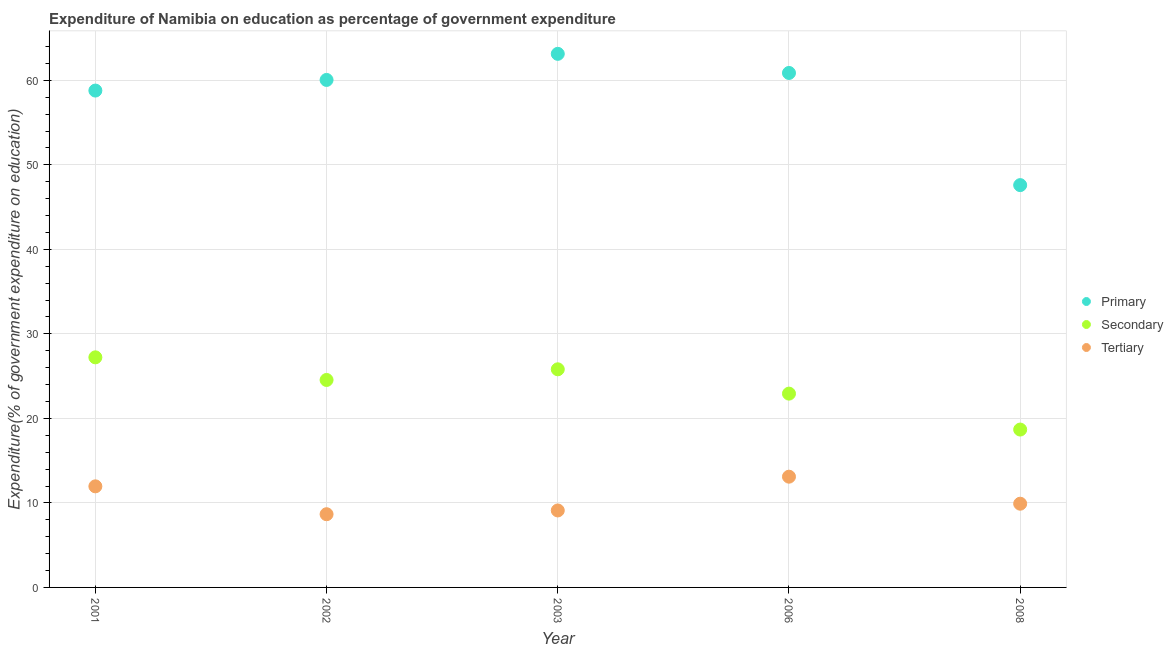What is the expenditure on tertiary education in 2008?
Offer a terse response. 9.91. Across all years, what is the maximum expenditure on tertiary education?
Your response must be concise. 13.1. Across all years, what is the minimum expenditure on tertiary education?
Ensure brevity in your answer.  8.66. What is the total expenditure on secondary education in the graph?
Provide a succinct answer. 119.19. What is the difference between the expenditure on primary education in 2001 and that in 2008?
Provide a succinct answer. 11.19. What is the difference between the expenditure on primary education in 2006 and the expenditure on tertiary education in 2002?
Keep it short and to the point. 52.21. What is the average expenditure on secondary education per year?
Offer a very short reply. 23.84. In the year 2003, what is the difference between the expenditure on secondary education and expenditure on primary education?
Provide a short and direct response. -37.32. What is the ratio of the expenditure on secondary education in 2001 to that in 2003?
Provide a succinct answer. 1.05. Is the expenditure on tertiary education in 2002 less than that in 2006?
Keep it short and to the point. Yes. What is the difference between the highest and the second highest expenditure on tertiary education?
Ensure brevity in your answer.  1.14. What is the difference between the highest and the lowest expenditure on secondary education?
Offer a very short reply. 8.55. In how many years, is the expenditure on primary education greater than the average expenditure on primary education taken over all years?
Offer a very short reply. 4. Is it the case that in every year, the sum of the expenditure on primary education and expenditure on secondary education is greater than the expenditure on tertiary education?
Ensure brevity in your answer.  Yes. How many dotlines are there?
Give a very brief answer. 3. Does the graph contain grids?
Ensure brevity in your answer.  Yes. What is the title of the graph?
Keep it short and to the point. Expenditure of Namibia on education as percentage of government expenditure. What is the label or title of the X-axis?
Keep it short and to the point. Year. What is the label or title of the Y-axis?
Give a very brief answer. Expenditure(% of government expenditure on education). What is the Expenditure(% of government expenditure on education) in Primary in 2001?
Offer a very short reply. 58.79. What is the Expenditure(% of government expenditure on education) in Secondary in 2001?
Your response must be concise. 27.22. What is the Expenditure(% of government expenditure on education) in Tertiary in 2001?
Ensure brevity in your answer.  11.96. What is the Expenditure(% of government expenditure on education) in Primary in 2002?
Ensure brevity in your answer.  60.05. What is the Expenditure(% of government expenditure on education) in Secondary in 2002?
Your answer should be very brief. 24.55. What is the Expenditure(% of government expenditure on education) of Tertiary in 2002?
Your response must be concise. 8.66. What is the Expenditure(% of government expenditure on education) in Primary in 2003?
Your response must be concise. 63.13. What is the Expenditure(% of government expenditure on education) in Secondary in 2003?
Your answer should be compact. 25.81. What is the Expenditure(% of government expenditure on education) in Tertiary in 2003?
Provide a succinct answer. 9.11. What is the Expenditure(% of government expenditure on education) in Primary in 2006?
Your answer should be very brief. 60.87. What is the Expenditure(% of government expenditure on education) in Secondary in 2006?
Your answer should be very brief. 22.93. What is the Expenditure(% of government expenditure on education) in Tertiary in 2006?
Offer a very short reply. 13.1. What is the Expenditure(% of government expenditure on education) in Primary in 2008?
Give a very brief answer. 47.6. What is the Expenditure(% of government expenditure on education) in Secondary in 2008?
Provide a short and direct response. 18.68. What is the Expenditure(% of government expenditure on education) of Tertiary in 2008?
Offer a terse response. 9.91. Across all years, what is the maximum Expenditure(% of government expenditure on education) in Primary?
Make the answer very short. 63.13. Across all years, what is the maximum Expenditure(% of government expenditure on education) in Secondary?
Provide a succinct answer. 27.22. Across all years, what is the maximum Expenditure(% of government expenditure on education) of Tertiary?
Offer a terse response. 13.1. Across all years, what is the minimum Expenditure(% of government expenditure on education) of Primary?
Your answer should be very brief. 47.6. Across all years, what is the minimum Expenditure(% of government expenditure on education) in Secondary?
Offer a very short reply. 18.68. Across all years, what is the minimum Expenditure(% of government expenditure on education) of Tertiary?
Provide a short and direct response. 8.66. What is the total Expenditure(% of government expenditure on education) in Primary in the graph?
Your answer should be compact. 290.44. What is the total Expenditure(% of government expenditure on education) of Secondary in the graph?
Make the answer very short. 119.19. What is the total Expenditure(% of government expenditure on education) in Tertiary in the graph?
Provide a succinct answer. 52.74. What is the difference between the Expenditure(% of government expenditure on education) of Primary in 2001 and that in 2002?
Your answer should be very brief. -1.26. What is the difference between the Expenditure(% of government expenditure on education) in Secondary in 2001 and that in 2002?
Ensure brevity in your answer.  2.68. What is the difference between the Expenditure(% of government expenditure on education) in Tertiary in 2001 and that in 2002?
Your answer should be very brief. 3.3. What is the difference between the Expenditure(% of government expenditure on education) in Primary in 2001 and that in 2003?
Give a very brief answer. -4.35. What is the difference between the Expenditure(% of government expenditure on education) in Secondary in 2001 and that in 2003?
Offer a terse response. 1.42. What is the difference between the Expenditure(% of government expenditure on education) of Tertiary in 2001 and that in 2003?
Offer a terse response. 2.85. What is the difference between the Expenditure(% of government expenditure on education) in Primary in 2001 and that in 2006?
Ensure brevity in your answer.  -2.08. What is the difference between the Expenditure(% of government expenditure on education) in Secondary in 2001 and that in 2006?
Offer a very short reply. 4.29. What is the difference between the Expenditure(% of government expenditure on education) in Tertiary in 2001 and that in 2006?
Your response must be concise. -1.14. What is the difference between the Expenditure(% of government expenditure on education) of Primary in 2001 and that in 2008?
Your response must be concise. 11.19. What is the difference between the Expenditure(% of government expenditure on education) of Secondary in 2001 and that in 2008?
Your answer should be compact. 8.55. What is the difference between the Expenditure(% of government expenditure on education) of Tertiary in 2001 and that in 2008?
Make the answer very short. 2.05. What is the difference between the Expenditure(% of government expenditure on education) in Primary in 2002 and that in 2003?
Keep it short and to the point. -3.09. What is the difference between the Expenditure(% of government expenditure on education) in Secondary in 2002 and that in 2003?
Your answer should be compact. -1.26. What is the difference between the Expenditure(% of government expenditure on education) of Tertiary in 2002 and that in 2003?
Offer a very short reply. -0.45. What is the difference between the Expenditure(% of government expenditure on education) in Primary in 2002 and that in 2006?
Your answer should be very brief. -0.83. What is the difference between the Expenditure(% of government expenditure on education) in Secondary in 2002 and that in 2006?
Keep it short and to the point. 1.62. What is the difference between the Expenditure(% of government expenditure on education) in Tertiary in 2002 and that in 2006?
Ensure brevity in your answer.  -4.44. What is the difference between the Expenditure(% of government expenditure on education) of Primary in 2002 and that in 2008?
Keep it short and to the point. 12.45. What is the difference between the Expenditure(% of government expenditure on education) of Secondary in 2002 and that in 2008?
Offer a terse response. 5.87. What is the difference between the Expenditure(% of government expenditure on education) in Tertiary in 2002 and that in 2008?
Your answer should be compact. -1.24. What is the difference between the Expenditure(% of government expenditure on education) in Primary in 2003 and that in 2006?
Your answer should be compact. 2.26. What is the difference between the Expenditure(% of government expenditure on education) of Secondary in 2003 and that in 2006?
Give a very brief answer. 2.88. What is the difference between the Expenditure(% of government expenditure on education) in Tertiary in 2003 and that in 2006?
Your response must be concise. -4. What is the difference between the Expenditure(% of government expenditure on education) of Primary in 2003 and that in 2008?
Your answer should be compact. 15.53. What is the difference between the Expenditure(% of government expenditure on education) of Secondary in 2003 and that in 2008?
Offer a terse response. 7.13. What is the difference between the Expenditure(% of government expenditure on education) of Tertiary in 2003 and that in 2008?
Your response must be concise. -0.8. What is the difference between the Expenditure(% of government expenditure on education) in Primary in 2006 and that in 2008?
Keep it short and to the point. 13.27. What is the difference between the Expenditure(% of government expenditure on education) of Secondary in 2006 and that in 2008?
Offer a terse response. 4.25. What is the difference between the Expenditure(% of government expenditure on education) in Tertiary in 2006 and that in 2008?
Ensure brevity in your answer.  3.2. What is the difference between the Expenditure(% of government expenditure on education) in Primary in 2001 and the Expenditure(% of government expenditure on education) in Secondary in 2002?
Offer a very short reply. 34.24. What is the difference between the Expenditure(% of government expenditure on education) of Primary in 2001 and the Expenditure(% of government expenditure on education) of Tertiary in 2002?
Your answer should be very brief. 50.13. What is the difference between the Expenditure(% of government expenditure on education) of Secondary in 2001 and the Expenditure(% of government expenditure on education) of Tertiary in 2002?
Your answer should be very brief. 18.56. What is the difference between the Expenditure(% of government expenditure on education) in Primary in 2001 and the Expenditure(% of government expenditure on education) in Secondary in 2003?
Give a very brief answer. 32.98. What is the difference between the Expenditure(% of government expenditure on education) of Primary in 2001 and the Expenditure(% of government expenditure on education) of Tertiary in 2003?
Keep it short and to the point. 49.68. What is the difference between the Expenditure(% of government expenditure on education) in Secondary in 2001 and the Expenditure(% of government expenditure on education) in Tertiary in 2003?
Give a very brief answer. 18.12. What is the difference between the Expenditure(% of government expenditure on education) in Primary in 2001 and the Expenditure(% of government expenditure on education) in Secondary in 2006?
Make the answer very short. 35.86. What is the difference between the Expenditure(% of government expenditure on education) of Primary in 2001 and the Expenditure(% of government expenditure on education) of Tertiary in 2006?
Your response must be concise. 45.68. What is the difference between the Expenditure(% of government expenditure on education) of Secondary in 2001 and the Expenditure(% of government expenditure on education) of Tertiary in 2006?
Ensure brevity in your answer.  14.12. What is the difference between the Expenditure(% of government expenditure on education) in Primary in 2001 and the Expenditure(% of government expenditure on education) in Secondary in 2008?
Make the answer very short. 40.11. What is the difference between the Expenditure(% of government expenditure on education) in Primary in 2001 and the Expenditure(% of government expenditure on education) in Tertiary in 2008?
Give a very brief answer. 48.88. What is the difference between the Expenditure(% of government expenditure on education) in Secondary in 2001 and the Expenditure(% of government expenditure on education) in Tertiary in 2008?
Provide a short and direct response. 17.32. What is the difference between the Expenditure(% of government expenditure on education) in Primary in 2002 and the Expenditure(% of government expenditure on education) in Secondary in 2003?
Keep it short and to the point. 34.24. What is the difference between the Expenditure(% of government expenditure on education) in Primary in 2002 and the Expenditure(% of government expenditure on education) in Tertiary in 2003?
Give a very brief answer. 50.94. What is the difference between the Expenditure(% of government expenditure on education) of Secondary in 2002 and the Expenditure(% of government expenditure on education) of Tertiary in 2003?
Ensure brevity in your answer.  15.44. What is the difference between the Expenditure(% of government expenditure on education) in Primary in 2002 and the Expenditure(% of government expenditure on education) in Secondary in 2006?
Ensure brevity in your answer.  37.12. What is the difference between the Expenditure(% of government expenditure on education) of Primary in 2002 and the Expenditure(% of government expenditure on education) of Tertiary in 2006?
Make the answer very short. 46.94. What is the difference between the Expenditure(% of government expenditure on education) in Secondary in 2002 and the Expenditure(% of government expenditure on education) in Tertiary in 2006?
Your answer should be compact. 11.44. What is the difference between the Expenditure(% of government expenditure on education) in Primary in 2002 and the Expenditure(% of government expenditure on education) in Secondary in 2008?
Your answer should be very brief. 41.37. What is the difference between the Expenditure(% of government expenditure on education) of Primary in 2002 and the Expenditure(% of government expenditure on education) of Tertiary in 2008?
Make the answer very short. 50.14. What is the difference between the Expenditure(% of government expenditure on education) of Secondary in 2002 and the Expenditure(% of government expenditure on education) of Tertiary in 2008?
Ensure brevity in your answer.  14.64. What is the difference between the Expenditure(% of government expenditure on education) of Primary in 2003 and the Expenditure(% of government expenditure on education) of Secondary in 2006?
Offer a terse response. 40.2. What is the difference between the Expenditure(% of government expenditure on education) of Primary in 2003 and the Expenditure(% of government expenditure on education) of Tertiary in 2006?
Give a very brief answer. 50.03. What is the difference between the Expenditure(% of government expenditure on education) of Secondary in 2003 and the Expenditure(% of government expenditure on education) of Tertiary in 2006?
Provide a succinct answer. 12.7. What is the difference between the Expenditure(% of government expenditure on education) of Primary in 2003 and the Expenditure(% of government expenditure on education) of Secondary in 2008?
Your answer should be very brief. 44.45. What is the difference between the Expenditure(% of government expenditure on education) in Primary in 2003 and the Expenditure(% of government expenditure on education) in Tertiary in 2008?
Give a very brief answer. 53.23. What is the difference between the Expenditure(% of government expenditure on education) of Secondary in 2003 and the Expenditure(% of government expenditure on education) of Tertiary in 2008?
Offer a very short reply. 15.9. What is the difference between the Expenditure(% of government expenditure on education) in Primary in 2006 and the Expenditure(% of government expenditure on education) in Secondary in 2008?
Your response must be concise. 42.19. What is the difference between the Expenditure(% of government expenditure on education) of Primary in 2006 and the Expenditure(% of government expenditure on education) of Tertiary in 2008?
Make the answer very short. 50.97. What is the difference between the Expenditure(% of government expenditure on education) of Secondary in 2006 and the Expenditure(% of government expenditure on education) of Tertiary in 2008?
Provide a succinct answer. 13.02. What is the average Expenditure(% of government expenditure on education) in Primary per year?
Offer a terse response. 58.09. What is the average Expenditure(% of government expenditure on education) in Secondary per year?
Your answer should be compact. 23.84. What is the average Expenditure(% of government expenditure on education) of Tertiary per year?
Your answer should be very brief. 10.55. In the year 2001, what is the difference between the Expenditure(% of government expenditure on education) in Primary and Expenditure(% of government expenditure on education) in Secondary?
Keep it short and to the point. 31.56. In the year 2001, what is the difference between the Expenditure(% of government expenditure on education) in Primary and Expenditure(% of government expenditure on education) in Tertiary?
Give a very brief answer. 46.83. In the year 2001, what is the difference between the Expenditure(% of government expenditure on education) of Secondary and Expenditure(% of government expenditure on education) of Tertiary?
Offer a very short reply. 15.26. In the year 2002, what is the difference between the Expenditure(% of government expenditure on education) in Primary and Expenditure(% of government expenditure on education) in Secondary?
Your response must be concise. 35.5. In the year 2002, what is the difference between the Expenditure(% of government expenditure on education) of Primary and Expenditure(% of government expenditure on education) of Tertiary?
Offer a very short reply. 51.38. In the year 2002, what is the difference between the Expenditure(% of government expenditure on education) in Secondary and Expenditure(% of government expenditure on education) in Tertiary?
Offer a terse response. 15.88. In the year 2003, what is the difference between the Expenditure(% of government expenditure on education) in Primary and Expenditure(% of government expenditure on education) in Secondary?
Offer a very short reply. 37.32. In the year 2003, what is the difference between the Expenditure(% of government expenditure on education) in Primary and Expenditure(% of government expenditure on education) in Tertiary?
Make the answer very short. 54.03. In the year 2003, what is the difference between the Expenditure(% of government expenditure on education) of Secondary and Expenditure(% of government expenditure on education) of Tertiary?
Your answer should be very brief. 16.7. In the year 2006, what is the difference between the Expenditure(% of government expenditure on education) of Primary and Expenditure(% of government expenditure on education) of Secondary?
Provide a succinct answer. 37.94. In the year 2006, what is the difference between the Expenditure(% of government expenditure on education) of Primary and Expenditure(% of government expenditure on education) of Tertiary?
Your response must be concise. 47.77. In the year 2006, what is the difference between the Expenditure(% of government expenditure on education) of Secondary and Expenditure(% of government expenditure on education) of Tertiary?
Ensure brevity in your answer.  9.83. In the year 2008, what is the difference between the Expenditure(% of government expenditure on education) of Primary and Expenditure(% of government expenditure on education) of Secondary?
Offer a terse response. 28.92. In the year 2008, what is the difference between the Expenditure(% of government expenditure on education) in Primary and Expenditure(% of government expenditure on education) in Tertiary?
Make the answer very short. 37.69. In the year 2008, what is the difference between the Expenditure(% of government expenditure on education) in Secondary and Expenditure(% of government expenditure on education) in Tertiary?
Your answer should be compact. 8.77. What is the ratio of the Expenditure(% of government expenditure on education) of Secondary in 2001 to that in 2002?
Offer a very short reply. 1.11. What is the ratio of the Expenditure(% of government expenditure on education) in Tertiary in 2001 to that in 2002?
Your answer should be compact. 1.38. What is the ratio of the Expenditure(% of government expenditure on education) in Primary in 2001 to that in 2003?
Offer a terse response. 0.93. What is the ratio of the Expenditure(% of government expenditure on education) of Secondary in 2001 to that in 2003?
Make the answer very short. 1.05. What is the ratio of the Expenditure(% of government expenditure on education) in Tertiary in 2001 to that in 2003?
Keep it short and to the point. 1.31. What is the ratio of the Expenditure(% of government expenditure on education) of Primary in 2001 to that in 2006?
Offer a terse response. 0.97. What is the ratio of the Expenditure(% of government expenditure on education) in Secondary in 2001 to that in 2006?
Ensure brevity in your answer.  1.19. What is the ratio of the Expenditure(% of government expenditure on education) in Tertiary in 2001 to that in 2006?
Provide a succinct answer. 0.91. What is the ratio of the Expenditure(% of government expenditure on education) of Primary in 2001 to that in 2008?
Provide a short and direct response. 1.24. What is the ratio of the Expenditure(% of government expenditure on education) in Secondary in 2001 to that in 2008?
Give a very brief answer. 1.46. What is the ratio of the Expenditure(% of government expenditure on education) in Tertiary in 2001 to that in 2008?
Offer a terse response. 1.21. What is the ratio of the Expenditure(% of government expenditure on education) of Primary in 2002 to that in 2003?
Your answer should be compact. 0.95. What is the ratio of the Expenditure(% of government expenditure on education) in Secondary in 2002 to that in 2003?
Offer a terse response. 0.95. What is the ratio of the Expenditure(% of government expenditure on education) in Tertiary in 2002 to that in 2003?
Provide a succinct answer. 0.95. What is the ratio of the Expenditure(% of government expenditure on education) in Primary in 2002 to that in 2006?
Offer a very short reply. 0.99. What is the ratio of the Expenditure(% of government expenditure on education) in Secondary in 2002 to that in 2006?
Your answer should be very brief. 1.07. What is the ratio of the Expenditure(% of government expenditure on education) of Tertiary in 2002 to that in 2006?
Your response must be concise. 0.66. What is the ratio of the Expenditure(% of government expenditure on education) of Primary in 2002 to that in 2008?
Offer a very short reply. 1.26. What is the ratio of the Expenditure(% of government expenditure on education) of Secondary in 2002 to that in 2008?
Ensure brevity in your answer.  1.31. What is the ratio of the Expenditure(% of government expenditure on education) of Tertiary in 2002 to that in 2008?
Your answer should be very brief. 0.87. What is the ratio of the Expenditure(% of government expenditure on education) in Primary in 2003 to that in 2006?
Your answer should be very brief. 1.04. What is the ratio of the Expenditure(% of government expenditure on education) of Secondary in 2003 to that in 2006?
Provide a succinct answer. 1.13. What is the ratio of the Expenditure(% of government expenditure on education) of Tertiary in 2003 to that in 2006?
Offer a very short reply. 0.69. What is the ratio of the Expenditure(% of government expenditure on education) in Primary in 2003 to that in 2008?
Offer a very short reply. 1.33. What is the ratio of the Expenditure(% of government expenditure on education) of Secondary in 2003 to that in 2008?
Ensure brevity in your answer.  1.38. What is the ratio of the Expenditure(% of government expenditure on education) in Tertiary in 2003 to that in 2008?
Make the answer very short. 0.92. What is the ratio of the Expenditure(% of government expenditure on education) in Primary in 2006 to that in 2008?
Your answer should be compact. 1.28. What is the ratio of the Expenditure(% of government expenditure on education) of Secondary in 2006 to that in 2008?
Your answer should be compact. 1.23. What is the ratio of the Expenditure(% of government expenditure on education) of Tertiary in 2006 to that in 2008?
Your response must be concise. 1.32. What is the difference between the highest and the second highest Expenditure(% of government expenditure on education) in Primary?
Provide a succinct answer. 2.26. What is the difference between the highest and the second highest Expenditure(% of government expenditure on education) of Secondary?
Provide a short and direct response. 1.42. What is the difference between the highest and the second highest Expenditure(% of government expenditure on education) of Tertiary?
Offer a very short reply. 1.14. What is the difference between the highest and the lowest Expenditure(% of government expenditure on education) in Primary?
Your answer should be very brief. 15.53. What is the difference between the highest and the lowest Expenditure(% of government expenditure on education) in Secondary?
Make the answer very short. 8.55. What is the difference between the highest and the lowest Expenditure(% of government expenditure on education) in Tertiary?
Offer a terse response. 4.44. 